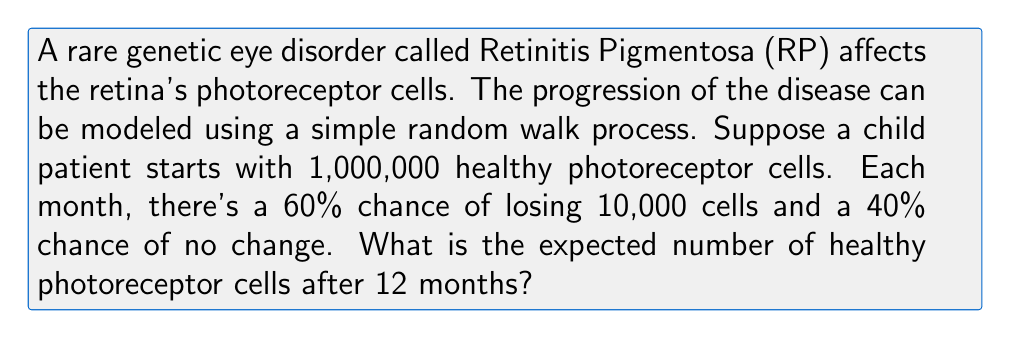Provide a solution to this math problem. Let's approach this step-by-step:

1) First, we need to understand the random walk process:
   - Each month is a step
   - Probability of losing 10,000 cells: $p = 0.6$
   - Probability of no change: $1-p = 0.4$

2) In a random walk, the expected position after $n$ steps is given by:
   $E(X_n) = X_0 + n(p_1\Delta_1 + p_2\Delta_2)$

   Where:
   $X_0$ is the starting position
   $n$ is the number of steps
   $p_1$ and $p_2$ are the probabilities of moving in each direction
   $\Delta_1$ and $\Delta_2$ are the size of the moves in each direction

3) In our case:
   $X_0 = 1,000,000$ (starting number of cells)
   $n = 12$ (months)
   $p_1 = 0.6$, $\Delta_1 = -10,000$ (losing cells)
   $p_2 = 0.4$, $\Delta_2 = 0$ (no change)

4) Plugging into the formula:
   $E(X_{12}) = 1,000,000 + 12(0.6 \cdot (-10,000) + 0.4 \cdot 0)$

5) Simplifying:
   $E(X_{12}) = 1,000,000 + 12(-6,000)$
   $E(X_{12}) = 1,000,000 - 72,000$
   $E(X_{12}) = 928,000$

Therefore, the expected number of healthy photoreceptor cells after 12 months is 928,000.
Answer: 928,000 cells 